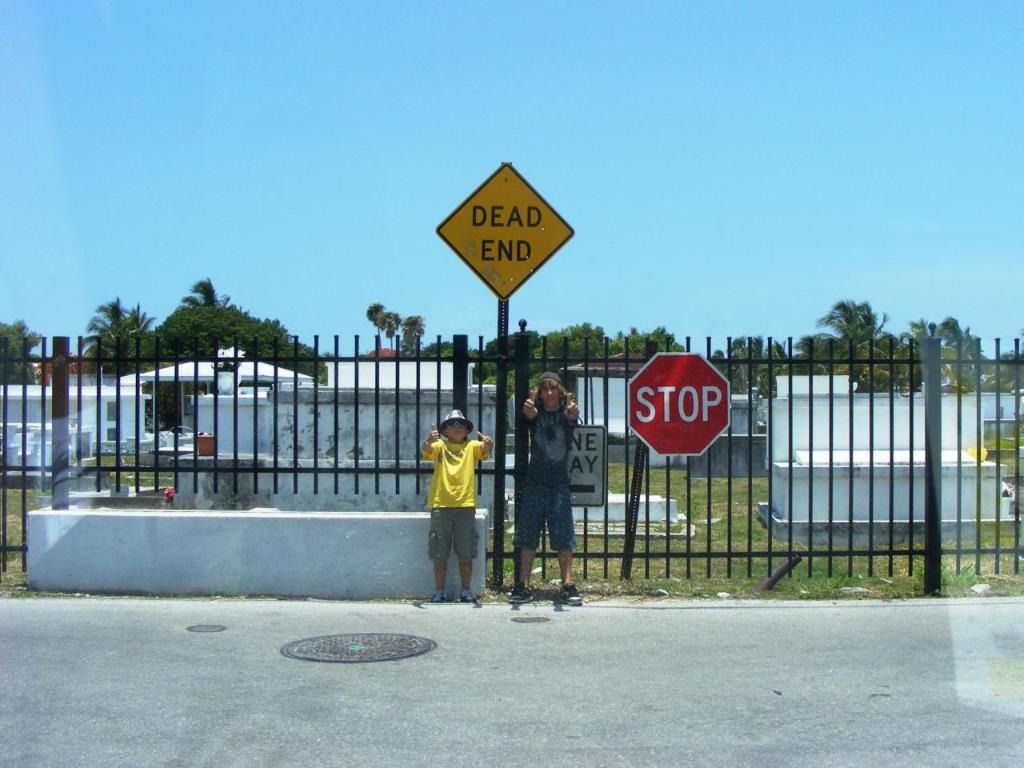<image>
Summarize the visual content of the image. Two kids are giving the thumbs up in front of a cemetery and a Dead End sign. 